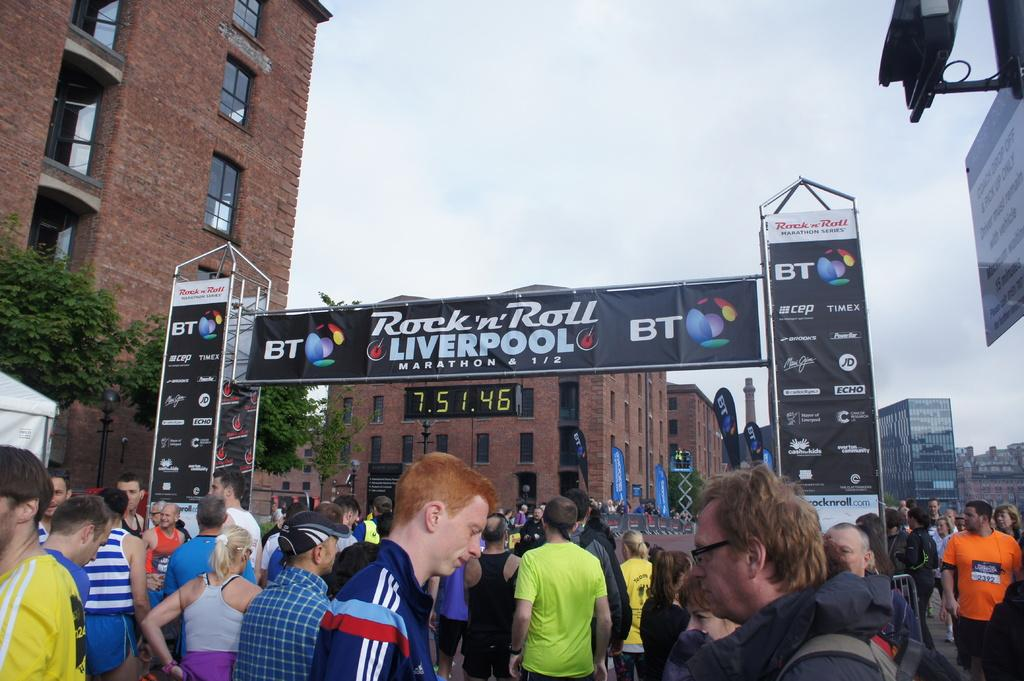<image>
Provide a brief description of the given image. The Rock 'n' Roll LIVERPOOL marathon series is going on with a crowd of people there. 